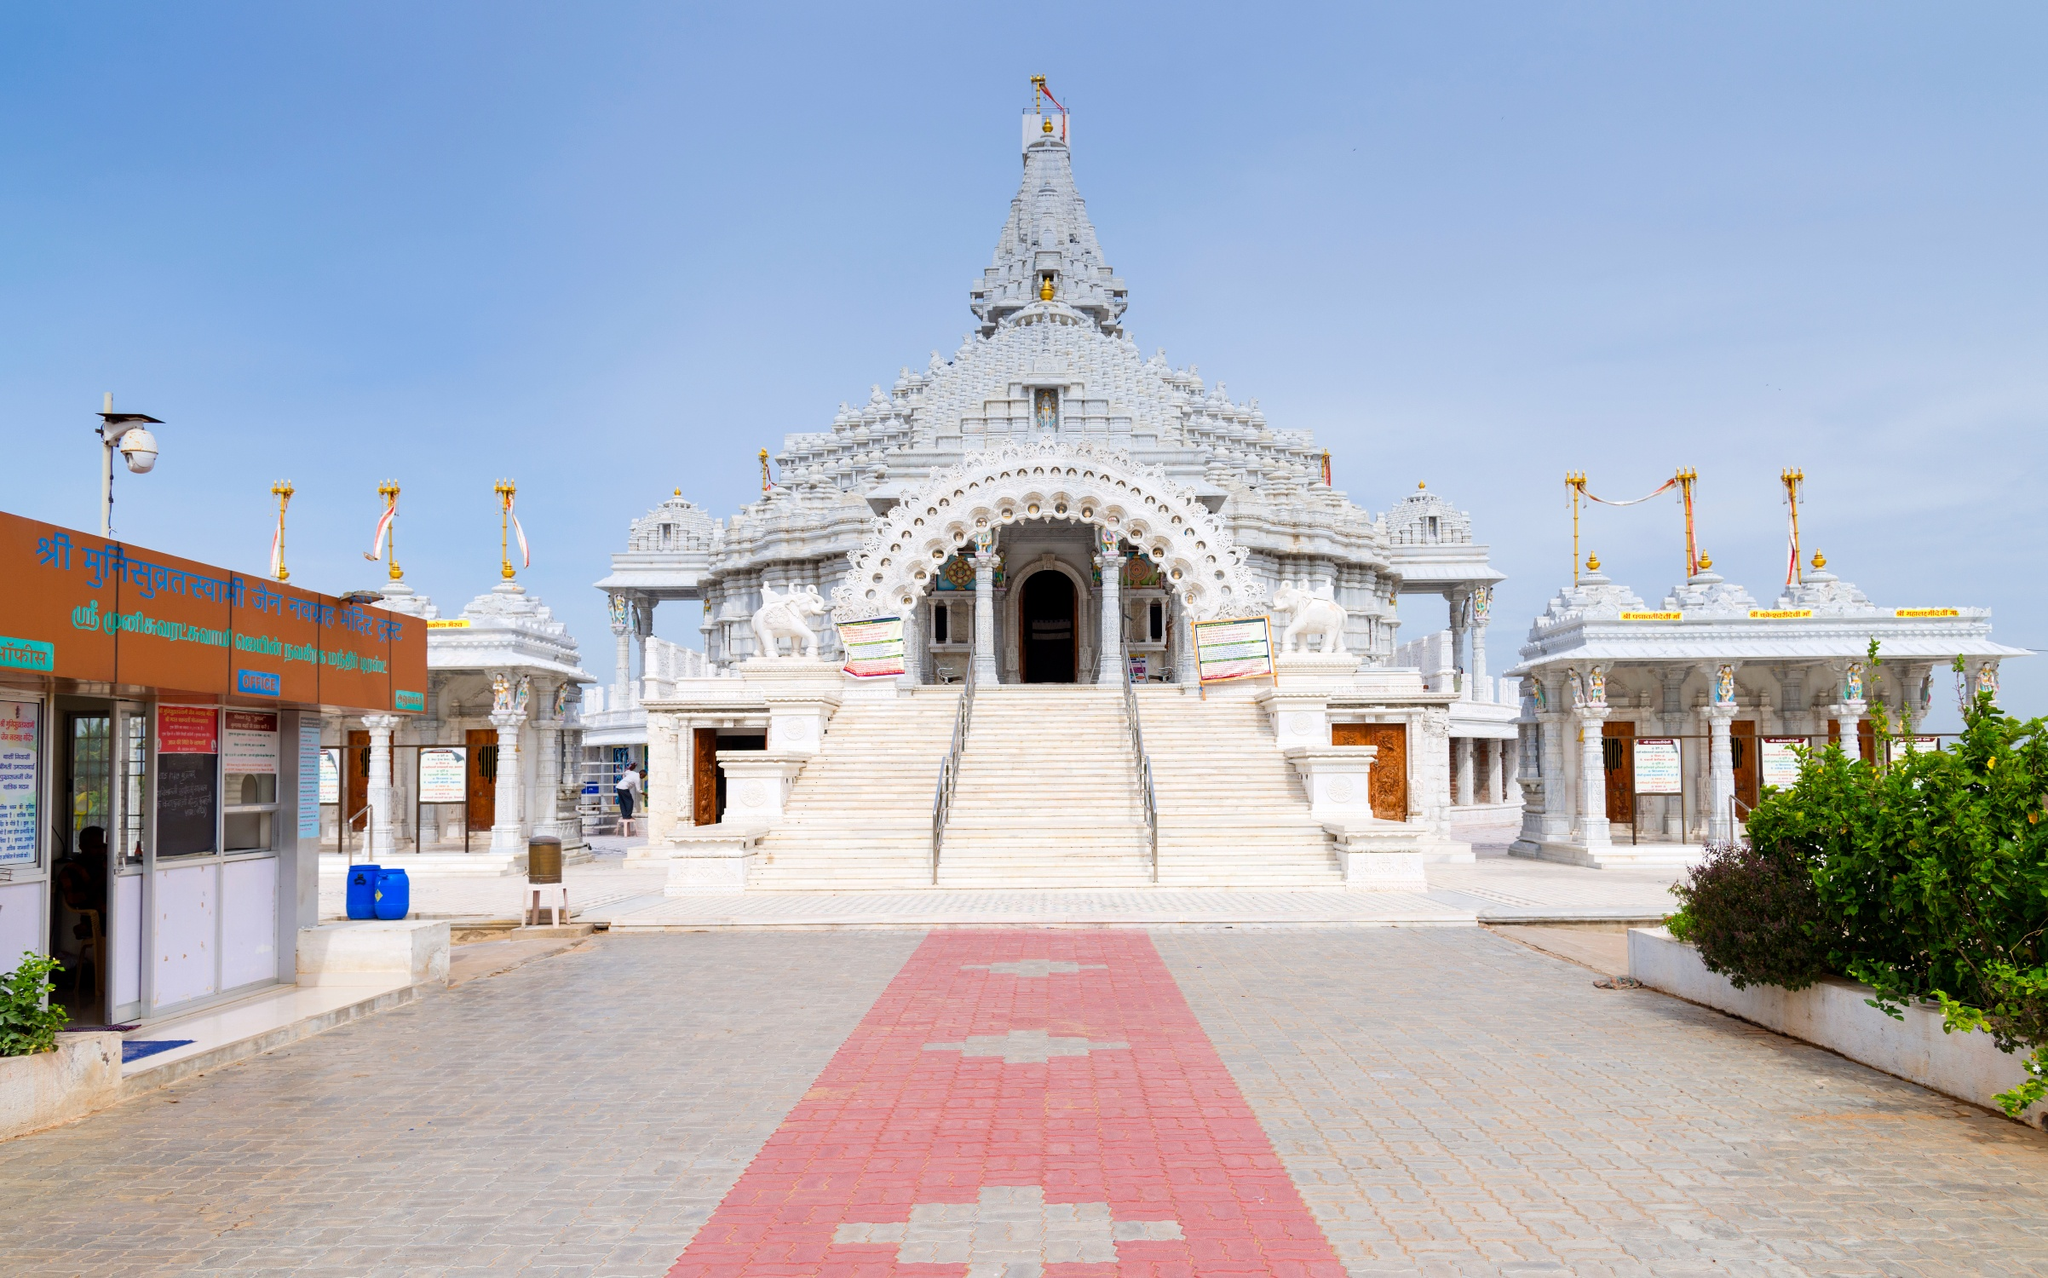Are there any particular stories or legends associated with temples like this one? While I can't provide specific legends related to this precise temple without more context, Hindu temples often serve as custodians of local myths and oral traditions. They are not just places of worship but also cultural hubs where stories of gods, goddesses, and heroes from epics like 'Mahabharata' and 'Ramayana' are told through sculptures and reliefs. These stories may portray the creation of the universe, battles between deities and demons, and moral tales that guide the community's values and practices. 